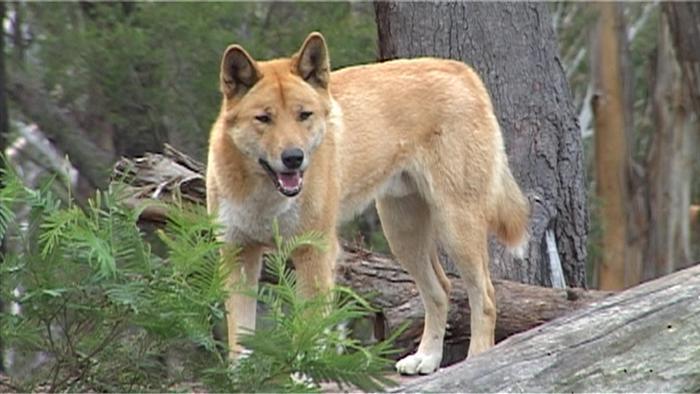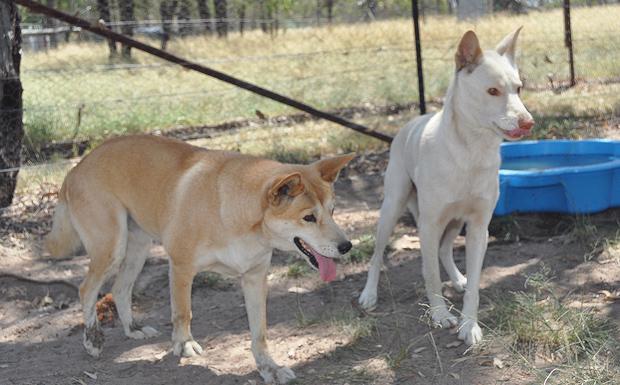The first image is the image on the left, the second image is the image on the right. Assess this claim about the two images: "The left image contains one standing dingo and a fallen log, and the right image contains exactly two standing dingos.". Correct or not? Answer yes or no. Yes. The first image is the image on the left, the second image is the image on the right. Evaluate the accuracy of this statement regarding the images: "One of the images contains a single dog in a wooded area.". Is it true? Answer yes or no. Yes. 